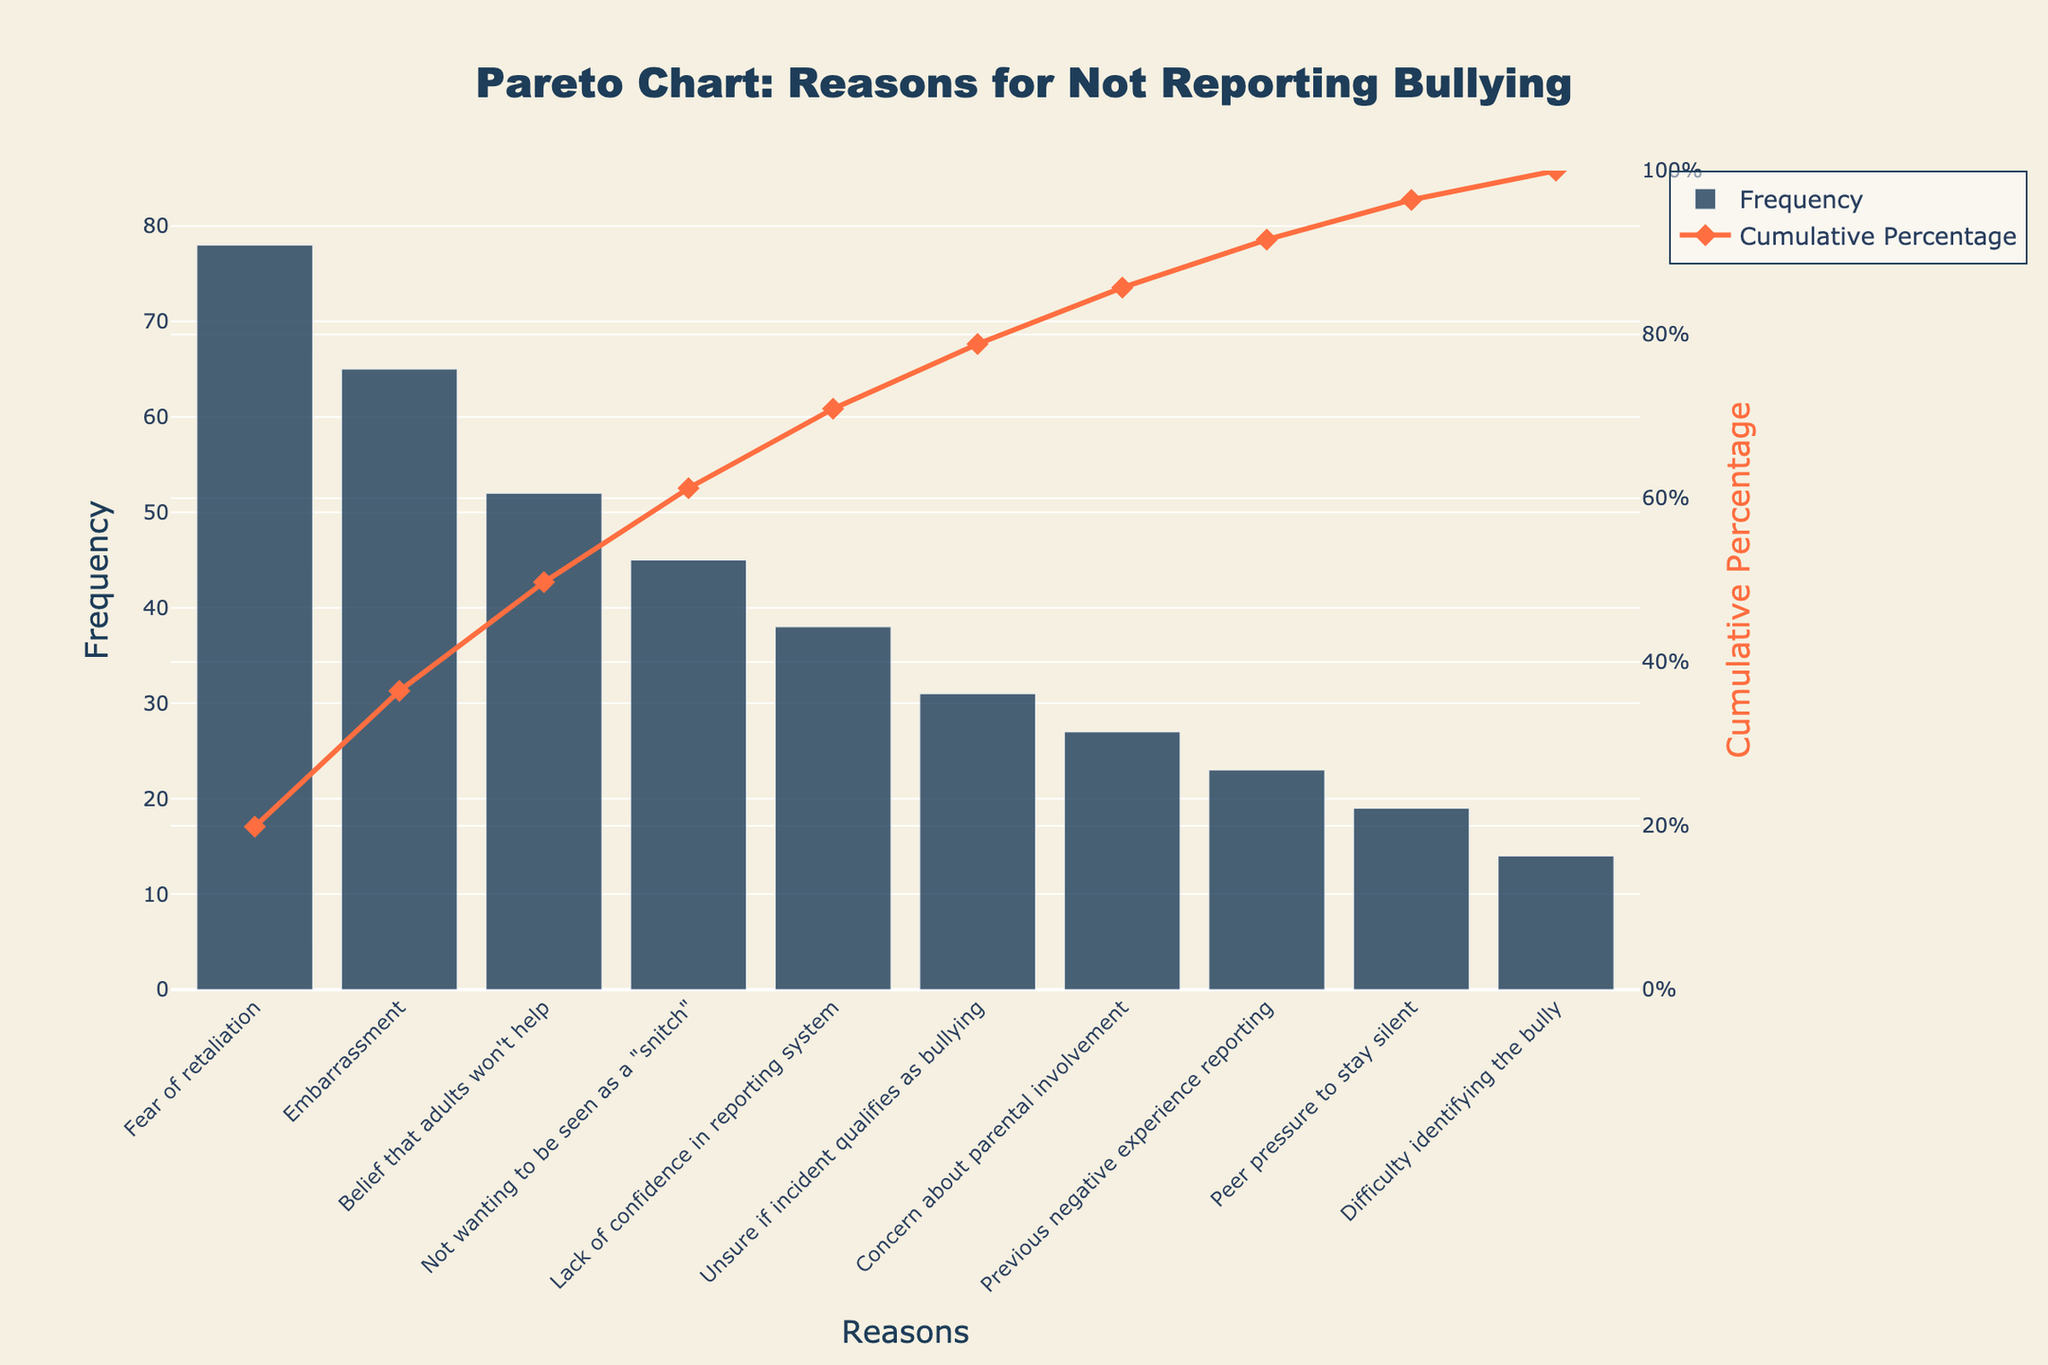What is the most frequently cited reason for not reporting bullying? The frequency can be determined by examining the highest bar on the Pareto chart, which represents the most commonly selected reason.
Answer: Fear of retaliation What is the cumulative percentage for the top three reasons for not reporting bullying? To find the cumulative percentage for the top three reasons, add their individual frequencies and divide by the total sum, then multiply by 100. Alternatively, refer directly to the cumulative percentage line in the chart for the top three reasons.
Answer: 61.4% Which reason has a frequency of 38? Identify the bar that corresponds to a frequency of 38 from the chart and find the associated reason.
Answer: Lack of confidence in reporting system How does "Embarrassment" compare to "Fear of retaliation" in terms of frequency? Compare the height of the bars representing "Embarrassment" and "Fear of retaliation" to see which one is higher (more frequent).
Answer: Fear of retaliation is more frequent What is the combined frequency of "Concern about parental involvement" and "Previous negative experience reporting"? Add the frequencies of "Concern about parental involvement" (27) and "Previous negative experience reporting" (23).
Answer: 50 What percentage of the frequency does "Not wanting to be seen as a 'snitch'" contribute to the total? Divide the frequency of "Not wanting to be seen as a 'snitch'" (45) by the total frequency sum, and multiply by 100.
Answer: 12.9% Is "Peer pressure to stay silent" more or less common than "Difficulty identifying the bully"? Compare the frequencies of "Peer pressure to stay silent" (19) and "Difficulty identifying the bully" (14).
Answer: More common What does the cumulative percentage look like after including the first five reasons? Find the cumulative percentage at the fifth reason by observing the plotted cumulative line on the chart.
Answer: 85.7% How many reasons accumulate to reach a cumulative percentage of nearly 100%? Count the number of reasons necessary until the cumulative line hits or approaches 100%.
Answer: 10 reasons Which visual element indicates the cumulative percentage throughout the reasons? Identify the element on the Pareto chart that shows cumulative percentages visually.
Answer: The orange line with diamonds 